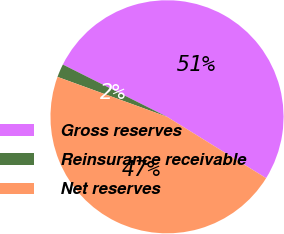Convert chart to OTSL. <chart><loc_0><loc_0><loc_500><loc_500><pie_chart><fcel>Gross reserves<fcel>Reinsurance receivable<fcel>Net reserves<nl><fcel>51.42%<fcel>1.84%<fcel>46.74%<nl></chart> 